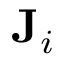Convert formula to latex. <formula><loc_0><loc_0><loc_500><loc_500>J _ { i }</formula> 